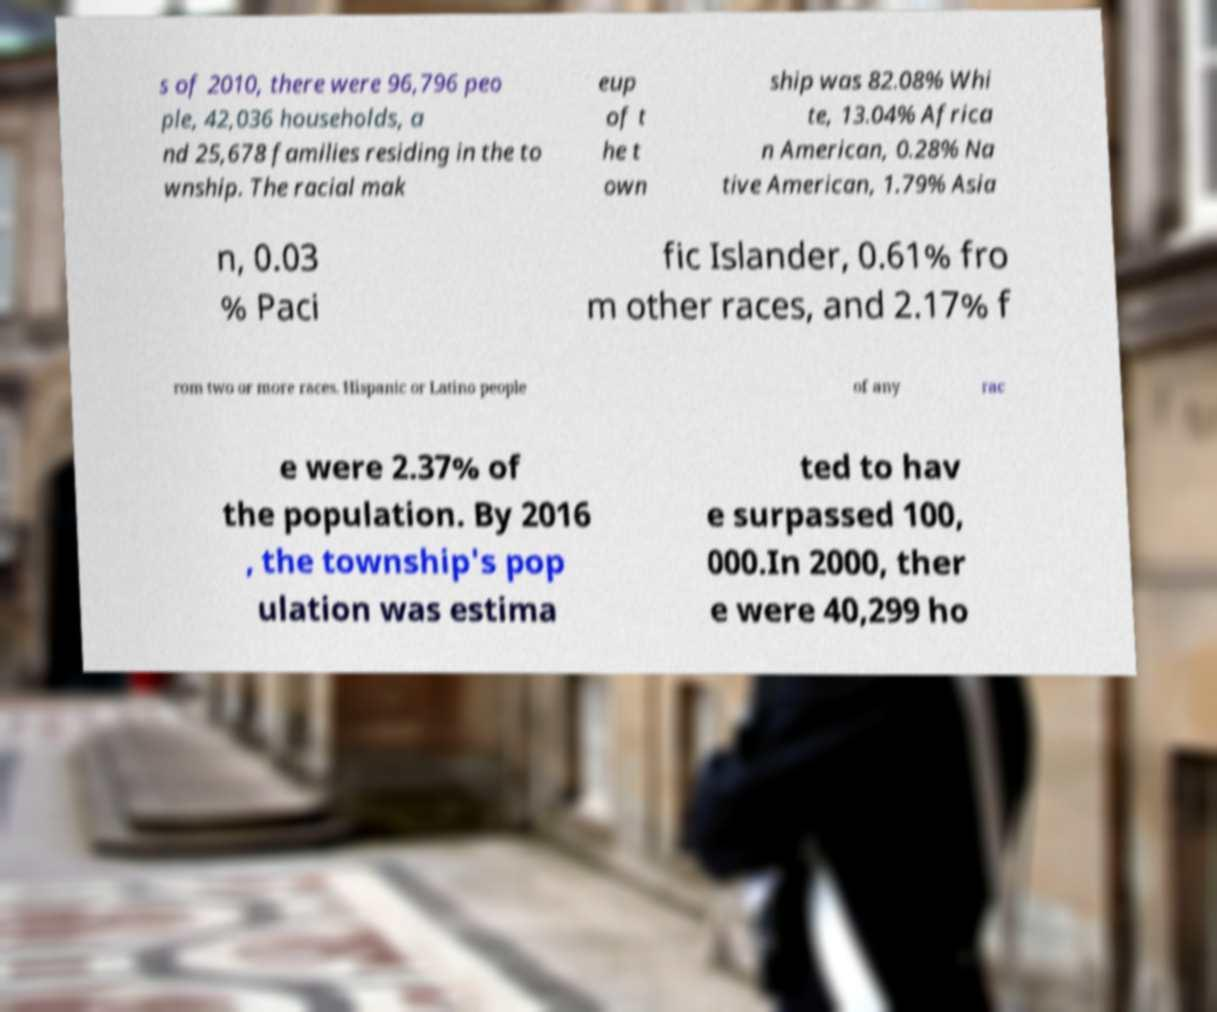Can you accurately transcribe the text from the provided image for me? s of 2010, there were 96,796 peo ple, 42,036 households, a nd 25,678 families residing in the to wnship. The racial mak eup of t he t own ship was 82.08% Whi te, 13.04% Africa n American, 0.28% Na tive American, 1.79% Asia n, 0.03 % Paci fic Islander, 0.61% fro m other races, and 2.17% f rom two or more races. Hispanic or Latino people of any rac e were 2.37% of the population. By 2016 , the township's pop ulation was estima ted to hav e surpassed 100, 000.In 2000, ther e were 40,299 ho 